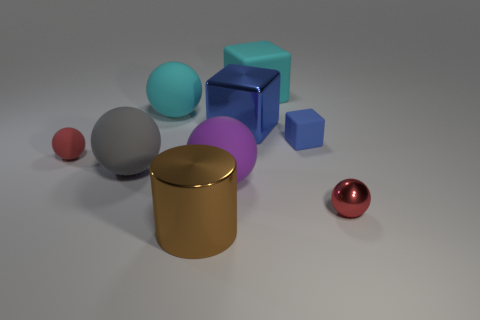Is the number of brown shiny objects greater than the number of large cyan matte things?
Your answer should be compact. No. What is the big blue cube made of?
Offer a very short reply. Metal. What is the color of the sphere that is behind the tiny rubber ball?
Keep it short and to the point. Cyan. Are there more blue matte blocks that are in front of the big purple thing than brown things left of the tiny red rubber sphere?
Give a very brief answer. No. There is a red thing on the left side of the big cyan rubber object behind the cyan thing to the left of the brown metal thing; how big is it?
Offer a terse response. Small. Is there a big rubber object of the same color as the small shiny sphere?
Provide a succinct answer. No. How many brown matte blocks are there?
Provide a short and direct response. 0. What material is the red object in front of the red object that is on the left side of the big cyan thing to the left of the brown cylinder made of?
Give a very brief answer. Metal. Is there a tiny red ball that has the same material as the big purple ball?
Keep it short and to the point. Yes. Are the big brown thing and the gray object made of the same material?
Provide a succinct answer. No. 